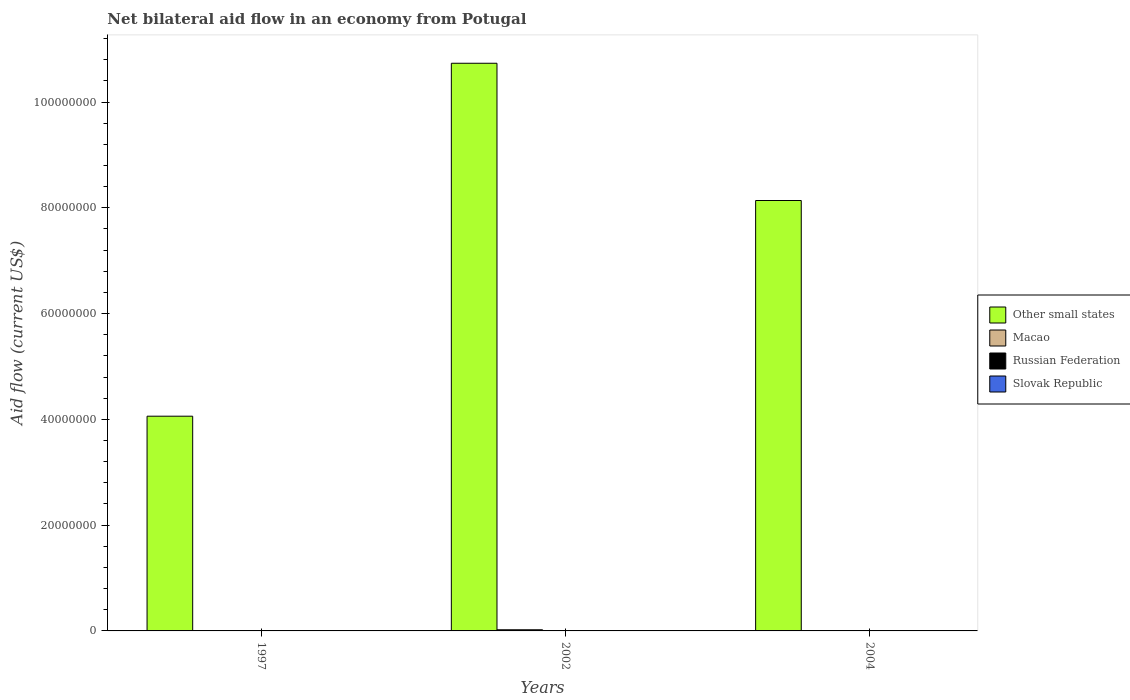How many groups of bars are there?
Give a very brief answer. 3. Are the number of bars on each tick of the X-axis equal?
Make the answer very short. Yes. How many bars are there on the 2nd tick from the left?
Your answer should be very brief. 4. How many bars are there on the 3rd tick from the right?
Keep it short and to the point. 4. What is the label of the 3rd group of bars from the left?
Your answer should be very brief. 2004. In how many cases, is the number of bars for a given year not equal to the number of legend labels?
Offer a terse response. 0. What is the net bilateral aid flow in Other small states in 1997?
Your answer should be compact. 4.06e+07. Across all years, what is the maximum net bilateral aid flow in Slovak Republic?
Provide a short and direct response. 10000. Across all years, what is the minimum net bilateral aid flow in Other small states?
Offer a terse response. 4.06e+07. What is the difference between the net bilateral aid flow in Macao in 2002 and that in 2004?
Your answer should be very brief. 1.80e+05. What is the difference between the net bilateral aid flow in Other small states in 2002 and the net bilateral aid flow in Russian Federation in 2004?
Offer a terse response. 1.07e+08. What is the average net bilateral aid flow in Russian Federation per year?
Your answer should be very brief. 4.00e+04. In the year 2002, what is the difference between the net bilateral aid flow in Slovak Republic and net bilateral aid flow in Macao?
Give a very brief answer. -2.10e+05. In how many years, is the net bilateral aid flow in Slovak Republic greater than 76000000 US$?
Make the answer very short. 0. What is the ratio of the net bilateral aid flow in Slovak Republic in 1997 to that in 2004?
Offer a terse response. 1. Is the net bilateral aid flow in Slovak Republic in 1997 less than that in 2002?
Offer a very short reply. No. Is the difference between the net bilateral aid flow in Slovak Republic in 1997 and 2002 greater than the difference between the net bilateral aid flow in Macao in 1997 and 2002?
Make the answer very short. Yes. What is the difference between the highest and the lowest net bilateral aid flow in Macao?
Provide a succinct answer. 2.10e+05. Is the sum of the net bilateral aid flow in Macao in 2002 and 2004 greater than the maximum net bilateral aid flow in Slovak Republic across all years?
Provide a short and direct response. Yes. Is it the case that in every year, the sum of the net bilateral aid flow in Macao and net bilateral aid flow in Slovak Republic is greater than the sum of net bilateral aid flow in Other small states and net bilateral aid flow in Russian Federation?
Make the answer very short. No. What does the 3rd bar from the left in 2002 represents?
Offer a terse response. Russian Federation. What does the 3rd bar from the right in 1997 represents?
Your answer should be very brief. Macao. Is it the case that in every year, the sum of the net bilateral aid flow in Russian Federation and net bilateral aid flow in Macao is greater than the net bilateral aid flow in Other small states?
Your answer should be compact. No. How many bars are there?
Provide a short and direct response. 12. Are all the bars in the graph horizontal?
Make the answer very short. No. Are the values on the major ticks of Y-axis written in scientific E-notation?
Your response must be concise. No. Does the graph contain grids?
Your answer should be very brief. No. How many legend labels are there?
Your answer should be compact. 4. How are the legend labels stacked?
Your answer should be compact. Vertical. What is the title of the graph?
Provide a short and direct response. Net bilateral aid flow in an economy from Potugal. Does "East Asia (developing only)" appear as one of the legend labels in the graph?
Give a very brief answer. No. What is the label or title of the X-axis?
Your answer should be compact. Years. What is the Aid flow (current US$) of Other small states in 1997?
Keep it short and to the point. 4.06e+07. What is the Aid flow (current US$) in Slovak Republic in 1997?
Provide a succinct answer. 10000. What is the Aid flow (current US$) of Other small states in 2002?
Provide a short and direct response. 1.07e+08. What is the Aid flow (current US$) of Slovak Republic in 2002?
Your answer should be very brief. 10000. What is the Aid flow (current US$) in Other small states in 2004?
Your response must be concise. 8.14e+07. What is the Aid flow (current US$) in Slovak Republic in 2004?
Give a very brief answer. 10000. Across all years, what is the maximum Aid flow (current US$) in Other small states?
Offer a terse response. 1.07e+08. Across all years, what is the maximum Aid flow (current US$) in Macao?
Keep it short and to the point. 2.20e+05. Across all years, what is the maximum Aid flow (current US$) in Slovak Republic?
Your answer should be very brief. 10000. Across all years, what is the minimum Aid flow (current US$) of Other small states?
Offer a terse response. 4.06e+07. Across all years, what is the minimum Aid flow (current US$) of Russian Federation?
Offer a terse response. 10000. Across all years, what is the minimum Aid flow (current US$) in Slovak Republic?
Keep it short and to the point. 10000. What is the total Aid flow (current US$) in Other small states in the graph?
Give a very brief answer. 2.29e+08. What is the total Aid flow (current US$) in Russian Federation in the graph?
Your answer should be very brief. 1.20e+05. What is the difference between the Aid flow (current US$) in Other small states in 1997 and that in 2002?
Offer a very short reply. -6.67e+07. What is the difference between the Aid flow (current US$) of Macao in 1997 and that in 2002?
Your answer should be very brief. -2.10e+05. What is the difference between the Aid flow (current US$) in Other small states in 1997 and that in 2004?
Keep it short and to the point. -4.08e+07. What is the difference between the Aid flow (current US$) of Other small states in 2002 and that in 2004?
Offer a very short reply. 2.60e+07. What is the difference between the Aid flow (current US$) of Russian Federation in 2002 and that in 2004?
Offer a very short reply. -3.00e+04. What is the difference between the Aid flow (current US$) in Other small states in 1997 and the Aid flow (current US$) in Macao in 2002?
Your answer should be very brief. 4.04e+07. What is the difference between the Aid flow (current US$) of Other small states in 1997 and the Aid flow (current US$) of Russian Federation in 2002?
Your answer should be very brief. 4.06e+07. What is the difference between the Aid flow (current US$) of Other small states in 1997 and the Aid flow (current US$) of Slovak Republic in 2002?
Offer a terse response. 4.06e+07. What is the difference between the Aid flow (current US$) in Macao in 1997 and the Aid flow (current US$) in Slovak Republic in 2002?
Your response must be concise. 0. What is the difference between the Aid flow (current US$) of Other small states in 1997 and the Aid flow (current US$) of Macao in 2004?
Keep it short and to the point. 4.06e+07. What is the difference between the Aid flow (current US$) of Other small states in 1997 and the Aid flow (current US$) of Russian Federation in 2004?
Your response must be concise. 4.05e+07. What is the difference between the Aid flow (current US$) in Other small states in 1997 and the Aid flow (current US$) in Slovak Republic in 2004?
Ensure brevity in your answer.  4.06e+07. What is the difference between the Aid flow (current US$) in Macao in 1997 and the Aid flow (current US$) in Russian Federation in 2004?
Offer a very short reply. -6.00e+04. What is the difference between the Aid flow (current US$) of Russian Federation in 1997 and the Aid flow (current US$) of Slovak Republic in 2004?
Make the answer very short. 0. What is the difference between the Aid flow (current US$) of Other small states in 2002 and the Aid flow (current US$) of Macao in 2004?
Ensure brevity in your answer.  1.07e+08. What is the difference between the Aid flow (current US$) of Other small states in 2002 and the Aid flow (current US$) of Russian Federation in 2004?
Your response must be concise. 1.07e+08. What is the difference between the Aid flow (current US$) in Other small states in 2002 and the Aid flow (current US$) in Slovak Republic in 2004?
Offer a very short reply. 1.07e+08. What is the difference between the Aid flow (current US$) of Macao in 2002 and the Aid flow (current US$) of Russian Federation in 2004?
Offer a very short reply. 1.50e+05. What is the difference between the Aid flow (current US$) in Macao in 2002 and the Aid flow (current US$) in Slovak Republic in 2004?
Offer a terse response. 2.10e+05. What is the difference between the Aid flow (current US$) of Russian Federation in 2002 and the Aid flow (current US$) of Slovak Republic in 2004?
Ensure brevity in your answer.  3.00e+04. What is the average Aid flow (current US$) of Other small states per year?
Your answer should be very brief. 7.64e+07. In the year 1997, what is the difference between the Aid flow (current US$) of Other small states and Aid flow (current US$) of Macao?
Ensure brevity in your answer.  4.06e+07. In the year 1997, what is the difference between the Aid flow (current US$) in Other small states and Aid flow (current US$) in Russian Federation?
Give a very brief answer. 4.06e+07. In the year 1997, what is the difference between the Aid flow (current US$) in Other small states and Aid flow (current US$) in Slovak Republic?
Offer a very short reply. 4.06e+07. In the year 2002, what is the difference between the Aid flow (current US$) of Other small states and Aid flow (current US$) of Macao?
Your answer should be very brief. 1.07e+08. In the year 2002, what is the difference between the Aid flow (current US$) in Other small states and Aid flow (current US$) in Russian Federation?
Make the answer very short. 1.07e+08. In the year 2002, what is the difference between the Aid flow (current US$) in Other small states and Aid flow (current US$) in Slovak Republic?
Keep it short and to the point. 1.07e+08. In the year 2002, what is the difference between the Aid flow (current US$) of Macao and Aid flow (current US$) of Russian Federation?
Your answer should be compact. 1.80e+05. In the year 2004, what is the difference between the Aid flow (current US$) of Other small states and Aid flow (current US$) of Macao?
Provide a short and direct response. 8.13e+07. In the year 2004, what is the difference between the Aid flow (current US$) in Other small states and Aid flow (current US$) in Russian Federation?
Offer a very short reply. 8.13e+07. In the year 2004, what is the difference between the Aid flow (current US$) in Other small states and Aid flow (current US$) in Slovak Republic?
Provide a short and direct response. 8.14e+07. In the year 2004, what is the difference between the Aid flow (current US$) of Russian Federation and Aid flow (current US$) of Slovak Republic?
Ensure brevity in your answer.  6.00e+04. What is the ratio of the Aid flow (current US$) in Other small states in 1997 to that in 2002?
Make the answer very short. 0.38. What is the ratio of the Aid flow (current US$) of Macao in 1997 to that in 2002?
Offer a terse response. 0.05. What is the ratio of the Aid flow (current US$) in Russian Federation in 1997 to that in 2002?
Keep it short and to the point. 0.25. What is the ratio of the Aid flow (current US$) of Slovak Republic in 1997 to that in 2002?
Your answer should be very brief. 1. What is the ratio of the Aid flow (current US$) in Other small states in 1997 to that in 2004?
Provide a succinct answer. 0.5. What is the ratio of the Aid flow (current US$) in Russian Federation in 1997 to that in 2004?
Your answer should be very brief. 0.14. What is the ratio of the Aid flow (current US$) of Slovak Republic in 1997 to that in 2004?
Your answer should be compact. 1. What is the ratio of the Aid flow (current US$) in Other small states in 2002 to that in 2004?
Ensure brevity in your answer.  1.32. What is the ratio of the Aid flow (current US$) of Slovak Republic in 2002 to that in 2004?
Keep it short and to the point. 1. What is the difference between the highest and the second highest Aid flow (current US$) in Other small states?
Provide a short and direct response. 2.60e+07. What is the difference between the highest and the second highest Aid flow (current US$) in Macao?
Make the answer very short. 1.80e+05. What is the difference between the highest and the second highest Aid flow (current US$) in Russian Federation?
Give a very brief answer. 3.00e+04. What is the difference between the highest and the lowest Aid flow (current US$) of Other small states?
Offer a very short reply. 6.67e+07. What is the difference between the highest and the lowest Aid flow (current US$) in Slovak Republic?
Your response must be concise. 0. 